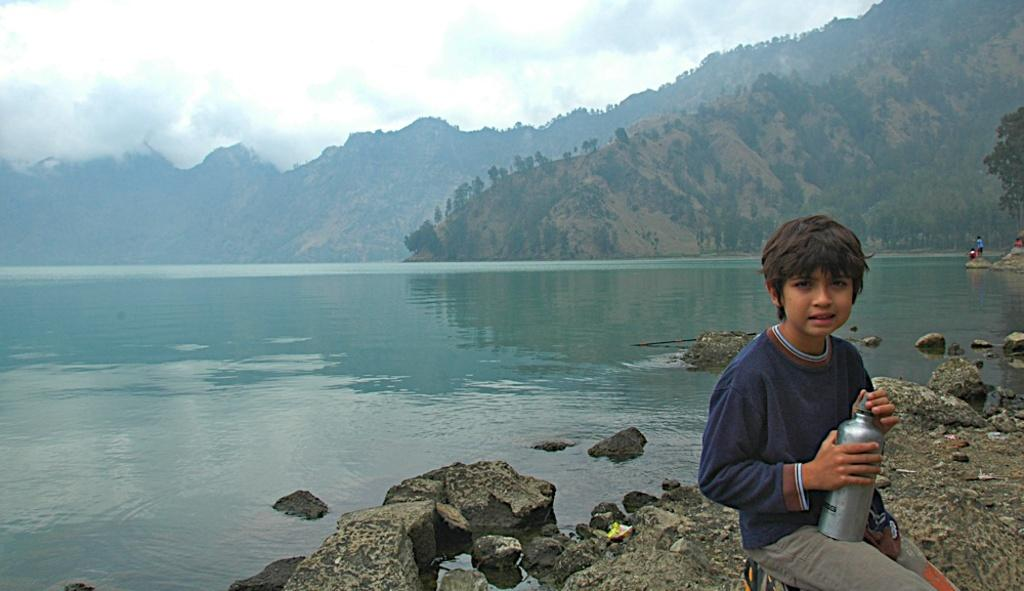What is the main subject of the image? There is a child in the image. What is the child doing in the image? The child is sitting on his toes and holding a bottle. What can be seen in the background of the image? There are people, water, mountains, and trees visible in the background of the image. How many geese are swimming in the water in the image? There are no geese present in the image; only people, water, mountains, and trees can be seen in the background. 